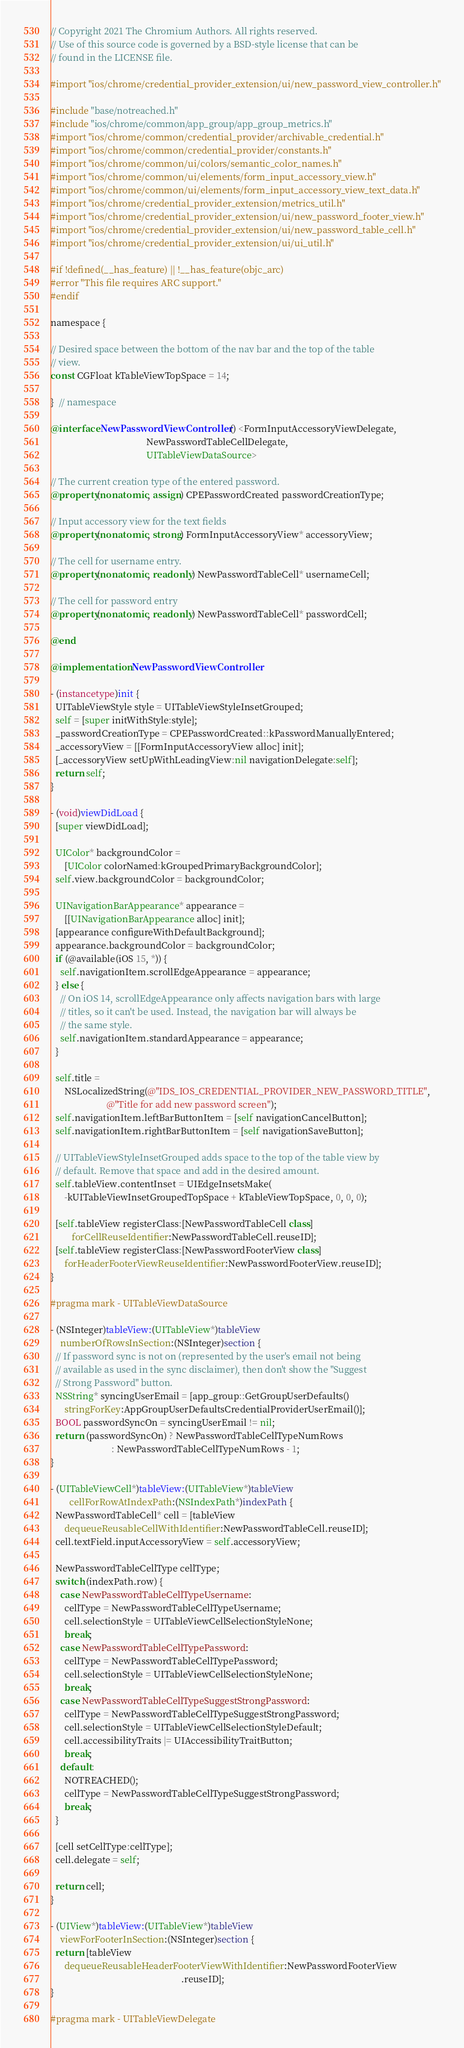<code> <loc_0><loc_0><loc_500><loc_500><_ObjectiveC_>// Copyright 2021 The Chromium Authors. All rights reserved.
// Use of this source code is governed by a BSD-style license that can be
// found in the LICENSE file.

#import "ios/chrome/credential_provider_extension/ui/new_password_view_controller.h"

#include "base/notreached.h"
#include "ios/chrome/common/app_group/app_group_metrics.h"
#import "ios/chrome/common/credential_provider/archivable_credential.h"
#import "ios/chrome/common/credential_provider/constants.h"
#import "ios/chrome/common/ui/colors/semantic_color_names.h"
#import "ios/chrome/common/ui/elements/form_input_accessory_view.h"
#import "ios/chrome/common/ui/elements/form_input_accessory_view_text_data.h"
#import "ios/chrome/credential_provider_extension/metrics_util.h"
#import "ios/chrome/credential_provider_extension/ui/new_password_footer_view.h"
#import "ios/chrome/credential_provider_extension/ui/new_password_table_cell.h"
#import "ios/chrome/credential_provider_extension/ui/ui_util.h"

#if !defined(__has_feature) || !__has_feature(objc_arc)
#error "This file requires ARC support."
#endif

namespace {

// Desired space between the bottom of the nav bar and the top of the table
// view.
const CGFloat kTableViewTopSpace = 14;

}  // namespace

@interface NewPasswordViewController () <FormInputAccessoryViewDelegate,
                                         NewPasswordTableCellDelegate,
                                         UITableViewDataSource>

// The current creation type of the entered password.
@property(nonatomic, assign) CPEPasswordCreated passwordCreationType;

// Input accessory view for the text fields
@property(nonatomic, strong) FormInputAccessoryView* accessoryView;

// The cell for username entry.
@property(nonatomic, readonly) NewPasswordTableCell* usernameCell;

// The cell for password entry
@property(nonatomic, readonly) NewPasswordTableCell* passwordCell;

@end

@implementation NewPasswordViewController

- (instancetype)init {
  UITableViewStyle style = UITableViewStyleInsetGrouped;
  self = [super initWithStyle:style];
  _passwordCreationType = CPEPasswordCreated::kPasswordManuallyEntered;
  _accessoryView = [[FormInputAccessoryView alloc] init];
  [_accessoryView setUpWithLeadingView:nil navigationDelegate:self];
  return self;
}

- (void)viewDidLoad {
  [super viewDidLoad];

  UIColor* backgroundColor =
      [UIColor colorNamed:kGroupedPrimaryBackgroundColor];
  self.view.backgroundColor = backgroundColor;

  UINavigationBarAppearance* appearance =
      [[UINavigationBarAppearance alloc] init];
  [appearance configureWithDefaultBackground];
  appearance.backgroundColor = backgroundColor;
  if (@available(iOS 15, *)) {
    self.navigationItem.scrollEdgeAppearance = appearance;
  } else {
    // On iOS 14, scrollEdgeAppearance only affects navigation bars with large
    // titles, so it can't be used. Instead, the navigation bar will always be
    // the same style.
    self.navigationItem.standardAppearance = appearance;
  }

  self.title =
      NSLocalizedString(@"IDS_IOS_CREDENTIAL_PROVIDER_NEW_PASSWORD_TITLE",
                        @"Title for add new password screen");
  self.navigationItem.leftBarButtonItem = [self navigationCancelButton];
  self.navigationItem.rightBarButtonItem = [self navigationSaveButton];

  // UITableViewStyleInsetGrouped adds space to the top of the table view by
  // default. Remove that space and add in the desired amount.
  self.tableView.contentInset = UIEdgeInsetsMake(
      -kUITableViewInsetGroupedTopSpace + kTableViewTopSpace, 0, 0, 0);

  [self.tableView registerClass:[NewPasswordTableCell class]
         forCellReuseIdentifier:NewPasswordTableCell.reuseID];
  [self.tableView registerClass:[NewPasswordFooterView class]
      forHeaderFooterViewReuseIdentifier:NewPasswordFooterView.reuseID];
}

#pragma mark - UITableViewDataSource

- (NSInteger)tableView:(UITableView*)tableView
    numberOfRowsInSection:(NSInteger)section {
  // If password sync is not on (represented by the user's email not being
  // available as used in the sync disclaimer), then don't show the "Suggest
  // Strong Password" button.
  NSString* syncingUserEmail = [app_group::GetGroupUserDefaults()
      stringForKey:AppGroupUserDefaultsCredentialProviderUserEmail()];
  BOOL passwordSyncOn = syncingUserEmail != nil;
  return (passwordSyncOn) ? NewPasswordTableCellTypeNumRows
                          : NewPasswordTableCellTypeNumRows - 1;
}

- (UITableViewCell*)tableView:(UITableView*)tableView
        cellForRowAtIndexPath:(NSIndexPath*)indexPath {
  NewPasswordTableCell* cell = [tableView
      dequeueReusableCellWithIdentifier:NewPasswordTableCell.reuseID];
  cell.textField.inputAccessoryView = self.accessoryView;

  NewPasswordTableCellType cellType;
  switch (indexPath.row) {
    case NewPasswordTableCellTypeUsername:
      cellType = NewPasswordTableCellTypeUsername;
      cell.selectionStyle = UITableViewCellSelectionStyleNone;
      break;
    case NewPasswordTableCellTypePassword:
      cellType = NewPasswordTableCellTypePassword;
      cell.selectionStyle = UITableViewCellSelectionStyleNone;
      break;
    case NewPasswordTableCellTypeSuggestStrongPassword:
      cellType = NewPasswordTableCellTypeSuggestStrongPassword;
      cell.selectionStyle = UITableViewCellSelectionStyleDefault;
      cell.accessibilityTraits |= UIAccessibilityTraitButton;
      break;
    default:
      NOTREACHED();
      cellType = NewPasswordTableCellTypeSuggestStrongPassword;
      break;
  }

  [cell setCellType:cellType];
  cell.delegate = self;

  return cell;
}

- (UIView*)tableView:(UITableView*)tableView
    viewForFooterInSection:(NSInteger)section {
  return [tableView
      dequeueReusableHeaderFooterViewWithIdentifier:NewPasswordFooterView
                                                        .reuseID];
}

#pragma mark - UITableViewDelegate
</code> 